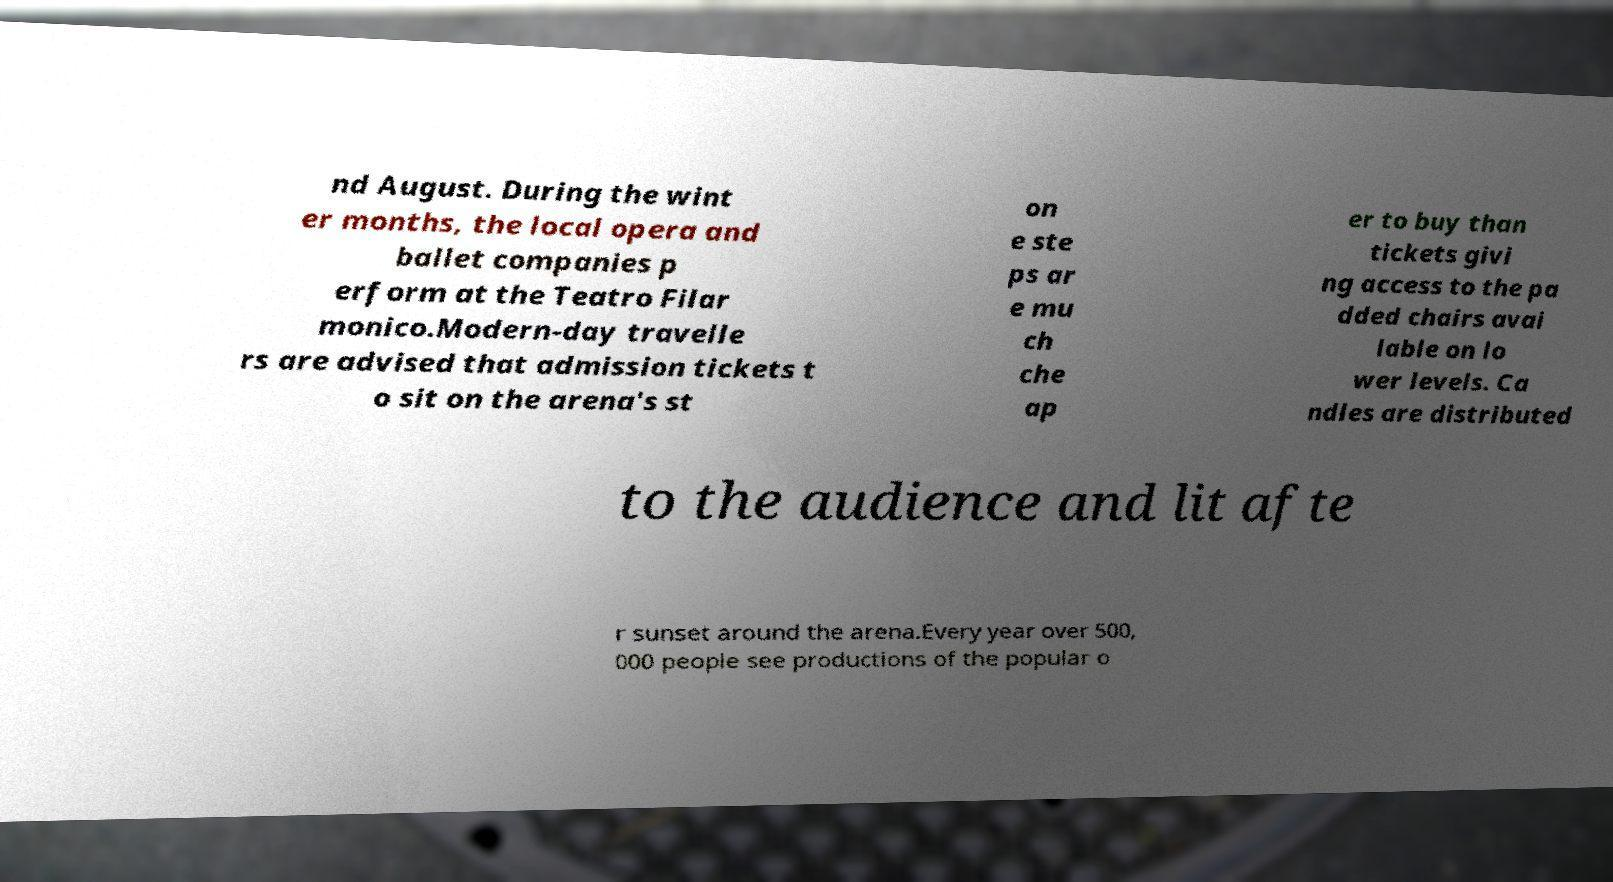I need the written content from this picture converted into text. Can you do that? nd August. During the wint er months, the local opera and ballet companies p erform at the Teatro Filar monico.Modern-day travelle rs are advised that admission tickets t o sit on the arena's st on e ste ps ar e mu ch che ap er to buy than tickets givi ng access to the pa dded chairs avai lable on lo wer levels. Ca ndles are distributed to the audience and lit afte r sunset around the arena.Every year over 500, 000 people see productions of the popular o 